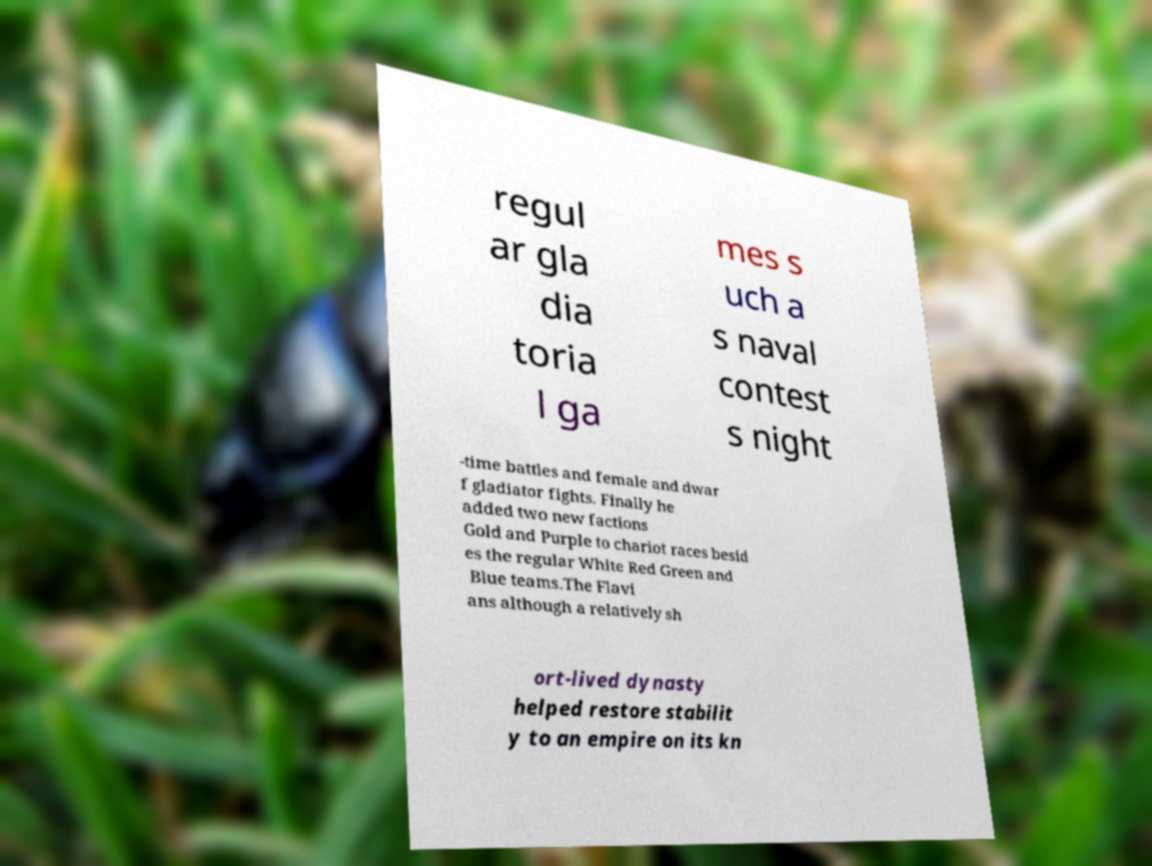Can you read and provide the text displayed in the image?This photo seems to have some interesting text. Can you extract and type it out for me? regul ar gla dia toria l ga mes s uch a s naval contest s night -time battles and female and dwar f gladiator fights. Finally he added two new factions Gold and Purple to chariot races besid es the regular White Red Green and Blue teams.The Flavi ans although a relatively sh ort-lived dynasty helped restore stabilit y to an empire on its kn 